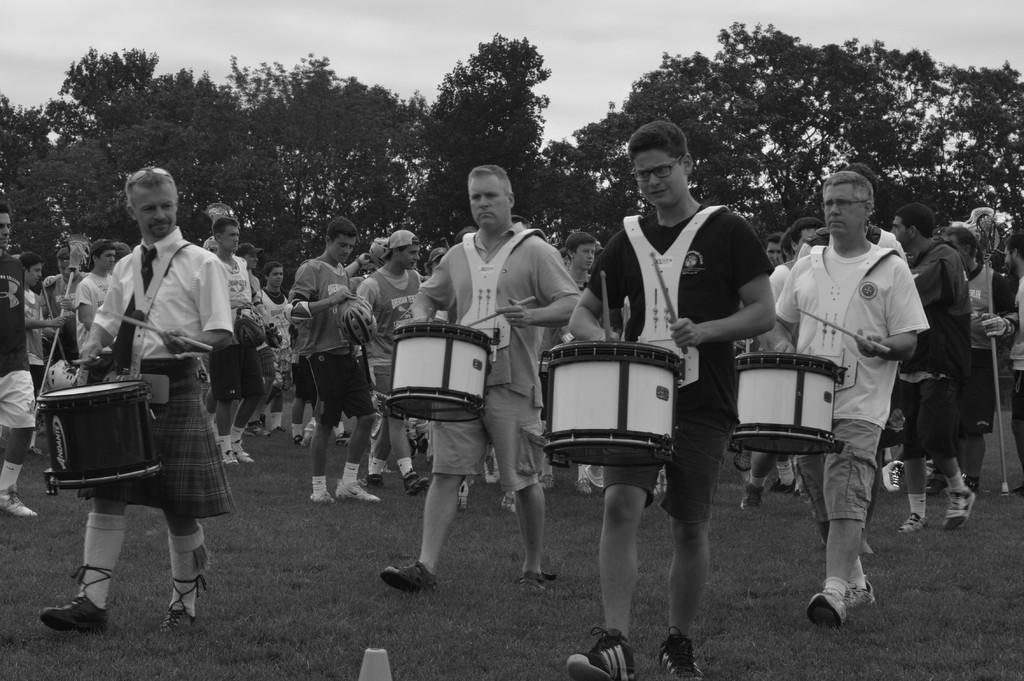Who or what can be seen in the image? There are people in the image. What are some of the people doing in the image? Some of the people are holding drums. What can be seen in the distance behind the people? There are trees in the background of the image. What type of station can be seen in the image? There is no station present in the image. Can you tell me how many turkeys are visible in the image? There are no turkeys present in the image. 